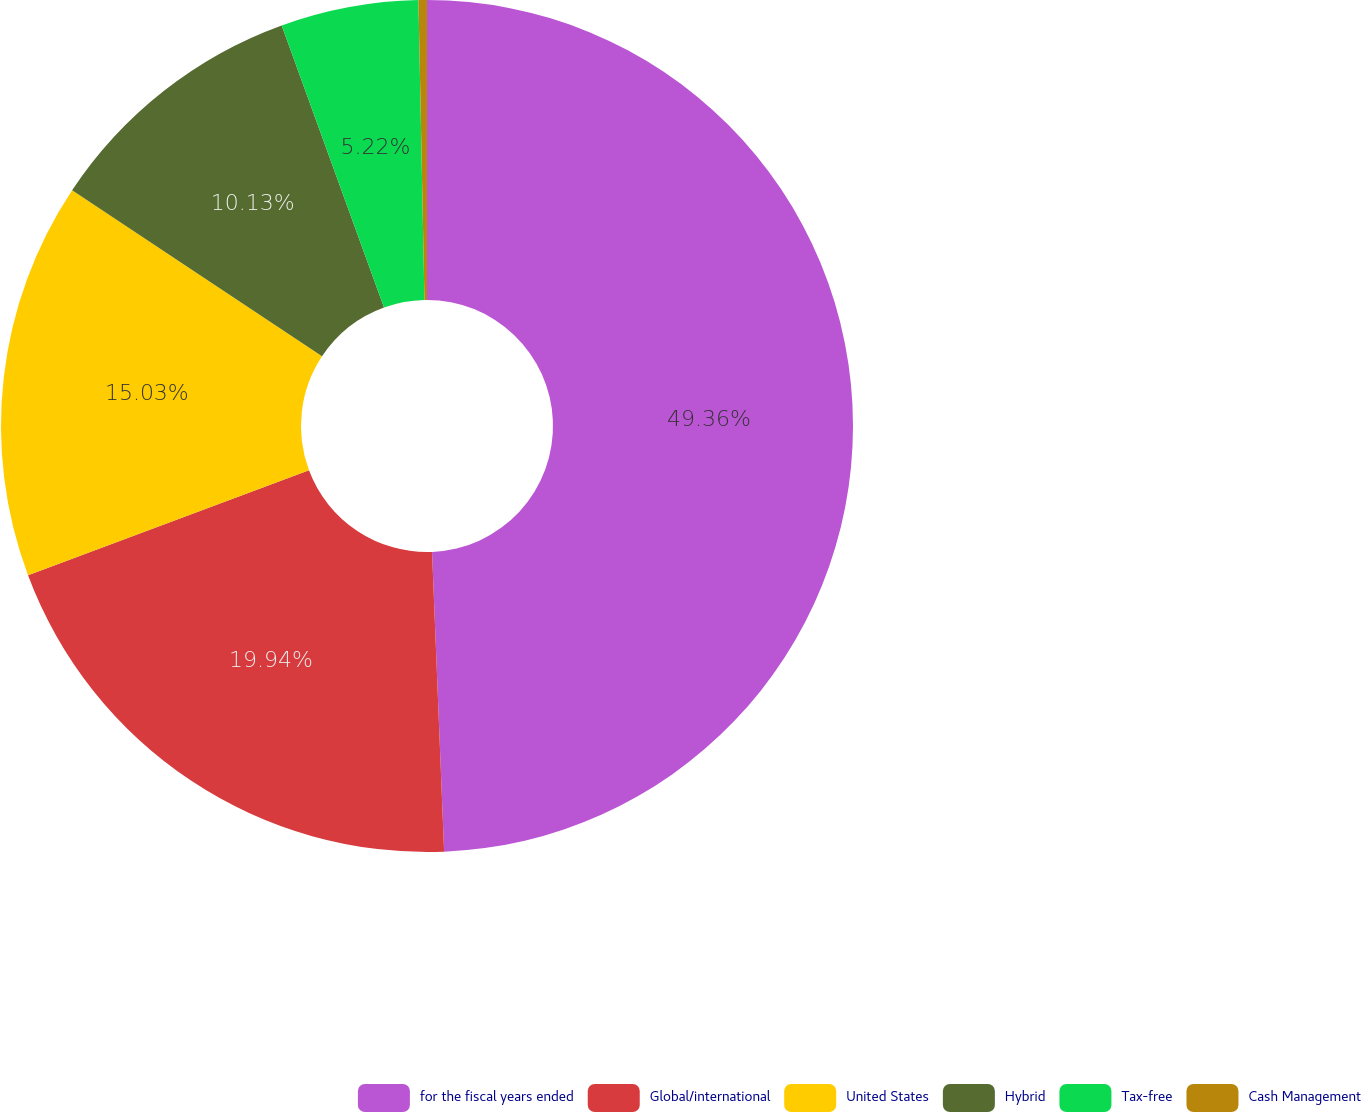Convert chart to OTSL. <chart><loc_0><loc_0><loc_500><loc_500><pie_chart><fcel>for the fiscal years ended<fcel>Global/international<fcel>United States<fcel>Hybrid<fcel>Tax-free<fcel>Cash Management<nl><fcel>49.36%<fcel>19.94%<fcel>15.03%<fcel>10.13%<fcel>5.22%<fcel>0.32%<nl></chart> 